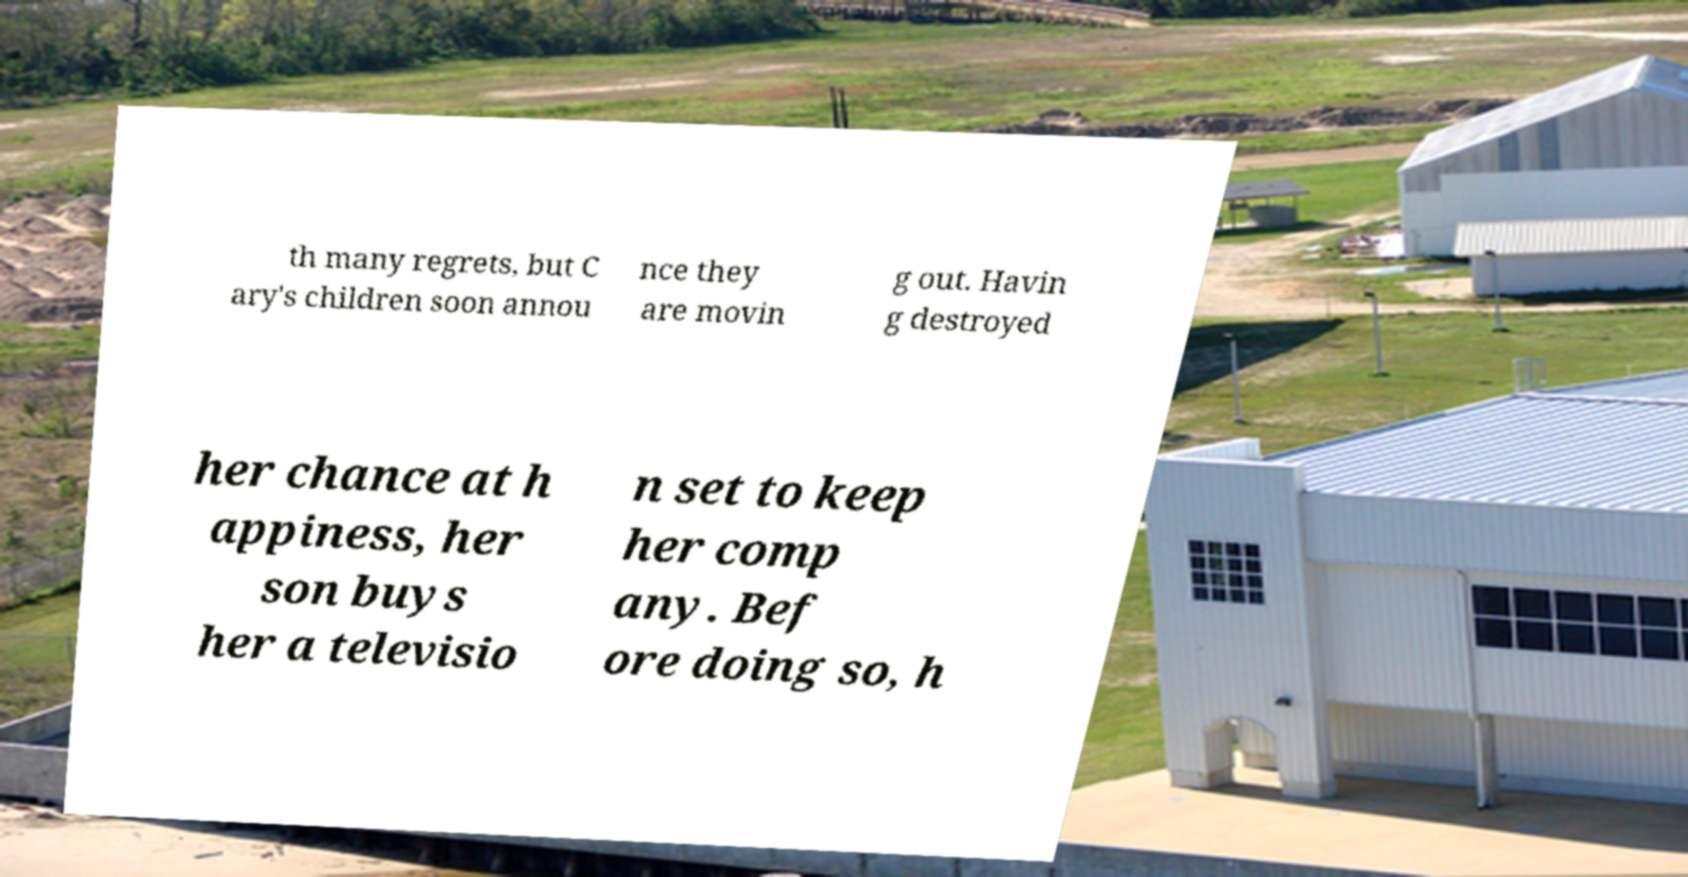Can you read and provide the text displayed in the image?This photo seems to have some interesting text. Can you extract and type it out for me? th many regrets, but C ary's children soon annou nce they are movin g out. Havin g destroyed her chance at h appiness, her son buys her a televisio n set to keep her comp any. Bef ore doing so, h 